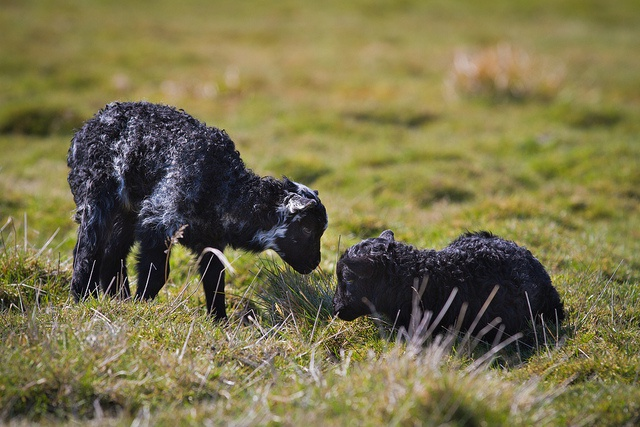Describe the objects in this image and their specific colors. I can see sheep in olive, black, gray, and darkgray tones and sheep in olive, black, and gray tones in this image. 